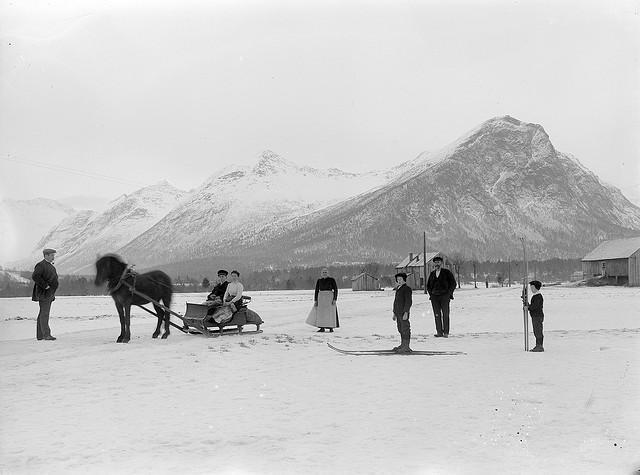How many animals are in this photo?
Give a very brief answer. 1. How many kids are here?
Give a very brief answer. 2. 